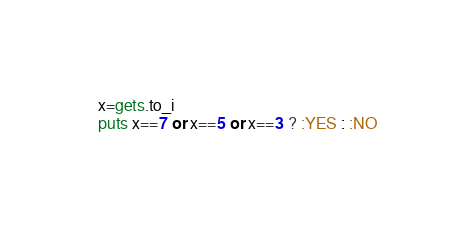<code> <loc_0><loc_0><loc_500><loc_500><_Ruby_>x=gets.to_i
puts x==7 or x==5 or x==3 ? :YES : :NO</code> 